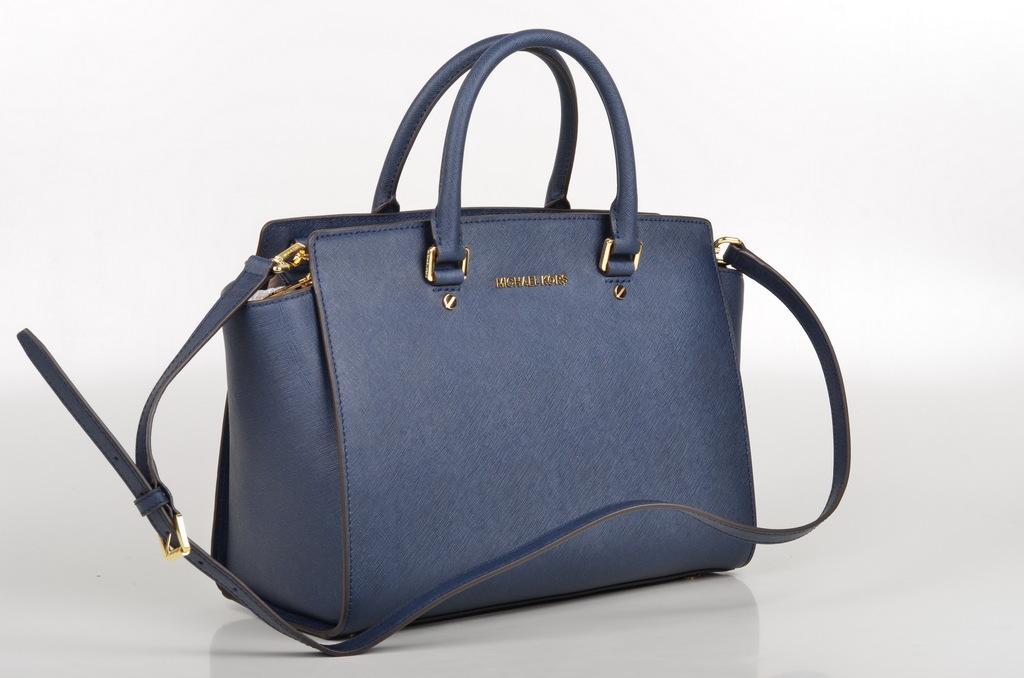Please provide a concise description of this image. In the image there is a bag which is in blue color. 